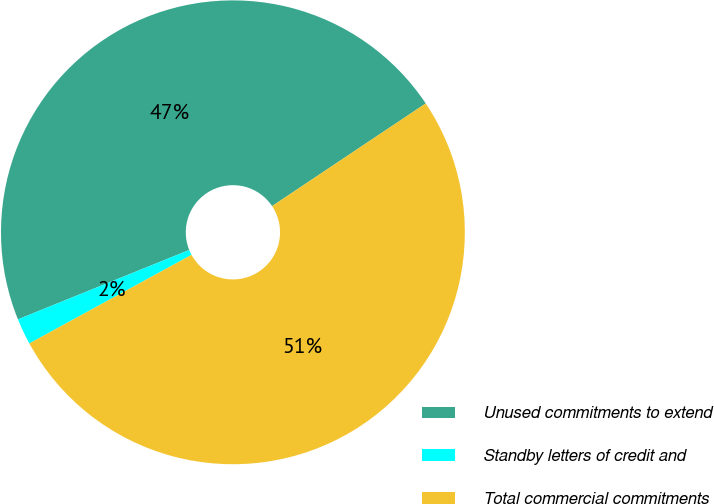Convert chart to OTSL. <chart><loc_0><loc_0><loc_500><loc_500><pie_chart><fcel>Unused commitments to extend<fcel>Standby letters of credit and<fcel>Total commercial commitments<nl><fcel>46.75%<fcel>1.83%<fcel>51.42%<nl></chart> 